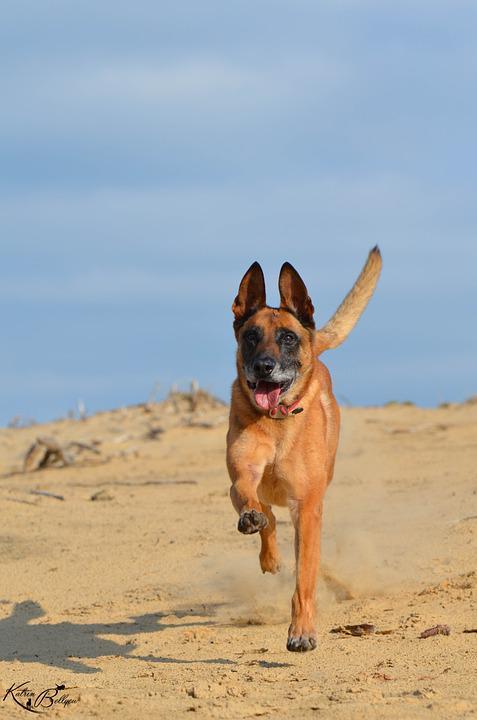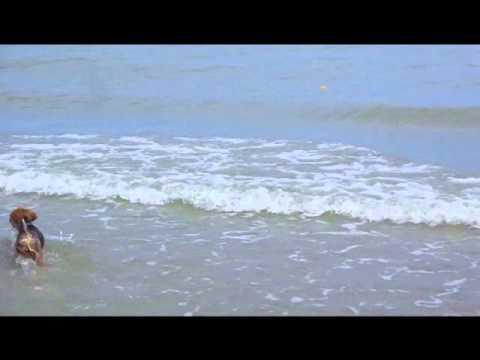The first image is the image on the left, the second image is the image on the right. For the images shown, is this caption "A dog with upright ears is bounding across the sand, and the ocean is visible in at least one image." true? Answer yes or no. Yes. The first image is the image on the left, the second image is the image on the right. For the images shown, is this caption "A single dog is standing legs and facing right in one of the images." true? Answer yes or no. No. 